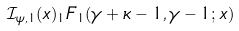Convert formula to latex. <formula><loc_0><loc_0><loc_500><loc_500>\mathcal { I } _ { \psi , 1 } ( x ) _ { 1 } F _ { 1 } ( \gamma + \kappa - 1 , \gamma - 1 ; x )</formula> 